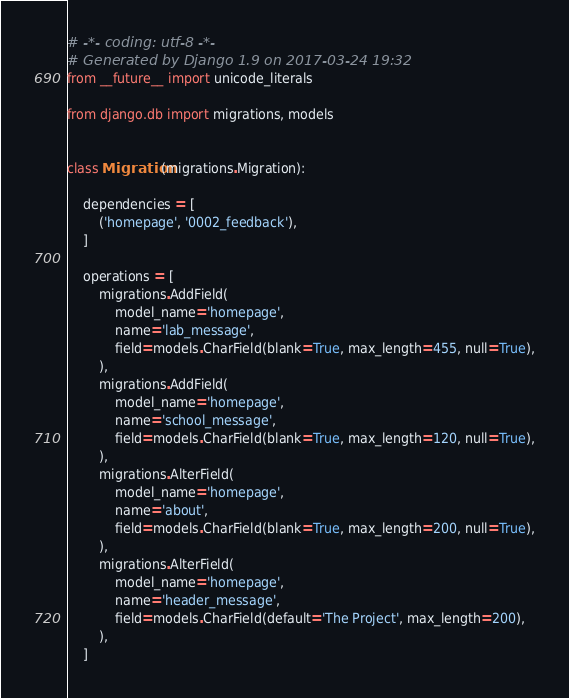Convert code to text. <code><loc_0><loc_0><loc_500><loc_500><_Python_># -*- coding: utf-8 -*-
# Generated by Django 1.9 on 2017-03-24 19:32
from __future__ import unicode_literals

from django.db import migrations, models


class Migration(migrations.Migration):

    dependencies = [
        ('homepage', '0002_feedback'),
    ]

    operations = [
        migrations.AddField(
            model_name='homepage',
            name='lab_message',
            field=models.CharField(blank=True, max_length=455, null=True),
        ),
        migrations.AddField(
            model_name='homepage',
            name='school_message',
            field=models.CharField(blank=True, max_length=120, null=True),
        ),
        migrations.AlterField(
            model_name='homepage',
            name='about',
            field=models.CharField(blank=True, max_length=200, null=True),
        ),
        migrations.AlterField(
            model_name='homepage',
            name='header_message',
            field=models.CharField(default='The Project', max_length=200),
        ),
    ]
</code> 